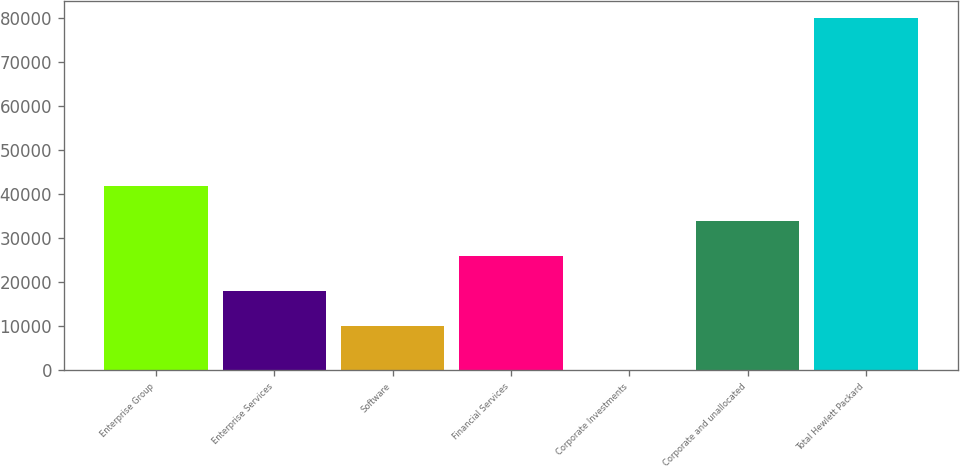Convert chart to OTSL. <chart><loc_0><loc_0><loc_500><loc_500><bar_chart><fcel>Enterprise Group<fcel>Enterprise Services<fcel>Software<fcel>Financial Services<fcel>Corporate Investments<fcel>Corporate and unallocated<fcel>Total Hewlett Packard<nl><fcel>41929.2<fcel>17979.3<fcel>9996<fcel>25962.6<fcel>83<fcel>33945.9<fcel>79916<nl></chart> 